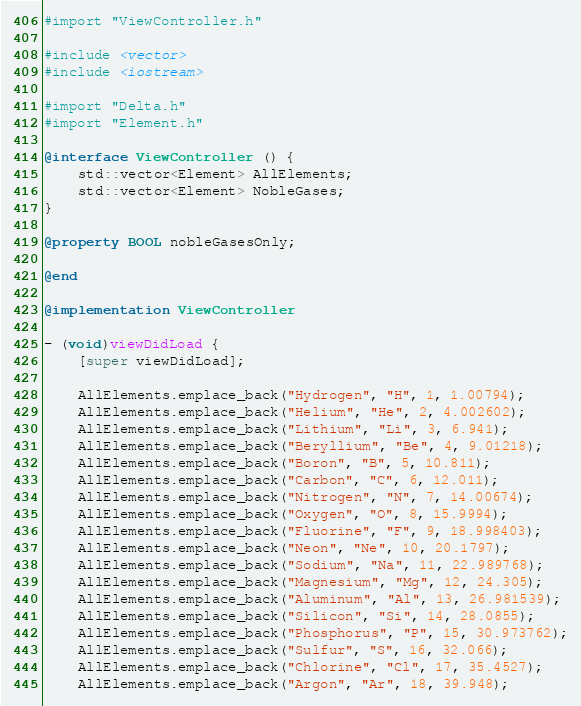<code> <loc_0><loc_0><loc_500><loc_500><_ObjectiveC_>#import "ViewController.h"

#include <vector>
#include <iostream>

#import "Delta.h"
#import "Element.h"

@interface ViewController () {
    std::vector<Element> AllElements;
    std::vector<Element> NobleGases;
}

@property BOOL nobleGasesOnly;

@end

@implementation ViewController

- (void)viewDidLoad {
    [super viewDidLoad];
    
    AllElements.emplace_back("Hydrogen", "H", 1, 1.00794);
    AllElements.emplace_back("Helium", "He", 2, 4.002602);
    AllElements.emplace_back("Lithium", "Li", 3, 6.941);
    AllElements.emplace_back("Beryllium", "Be", 4, 9.01218);
    AllElements.emplace_back("Boron", "B", 5, 10.811);
    AllElements.emplace_back("Carbon", "C", 6, 12.011);
    AllElements.emplace_back("Nitrogen", "N", 7, 14.00674);
    AllElements.emplace_back("Oxygen", "O", 8, 15.9994);
    AllElements.emplace_back("Fluorine", "F", 9, 18.998403);
    AllElements.emplace_back("Neon", "Ne", 10, 20.1797);
    AllElements.emplace_back("Sodium", "Na", 11, 22.989768);
    AllElements.emplace_back("Magnesium", "Mg", 12, 24.305);
    AllElements.emplace_back("Aluminum", "Al", 13, 26.981539);
    AllElements.emplace_back("Silicon", "Si", 14, 28.0855);
    AllElements.emplace_back("Phosphorus", "P", 15, 30.973762);
    AllElements.emplace_back("Sulfur", "S", 16, 32.066);
    AllElements.emplace_back("Chlorine", "Cl", 17, 35.4527);
    AllElements.emplace_back("Argon", "Ar", 18, 39.948);</code> 